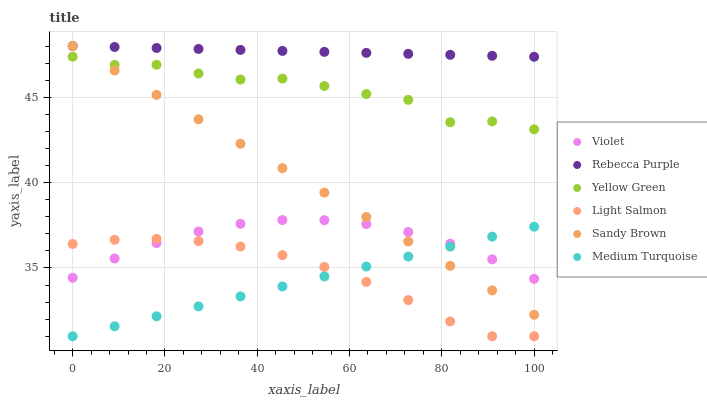Does Medium Turquoise have the minimum area under the curve?
Answer yes or no. Yes. Does Rebecca Purple have the maximum area under the curve?
Answer yes or no. Yes. Does Yellow Green have the minimum area under the curve?
Answer yes or no. No. Does Yellow Green have the maximum area under the curve?
Answer yes or no. No. Is Rebecca Purple the smoothest?
Answer yes or no. Yes. Is Yellow Green the roughest?
Answer yes or no. Yes. Is Yellow Green the smoothest?
Answer yes or no. No. Is Rebecca Purple the roughest?
Answer yes or no. No. Does Light Salmon have the lowest value?
Answer yes or no. Yes. Does Yellow Green have the lowest value?
Answer yes or no. No. Does Sandy Brown have the highest value?
Answer yes or no. Yes. Does Yellow Green have the highest value?
Answer yes or no. No. Is Light Salmon less than Sandy Brown?
Answer yes or no. Yes. Is Yellow Green greater than Violet?
Answer yes or no. Yes. Does Yellow Green intersect Sandy Brown?
Answer yes or no. Yes. Is Yellow Green less than Sandy Brown?
Answer yes or no. No. Is Yellow Green greater than Sandy Brown?
Answer yes or no. No. Does Light Salmon intersect Sandy Brown?
Answer yes or no. No. 